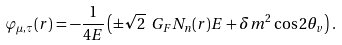<formula> <loc_0><loc_0><loc_500><loc_500>\varphi _ { \mu , \tau } ( r ) = - \frac { 1 } { 4 E } \left ( \pm \sqrt { 2 } \ G _ { F } N _ { n } ( r ) E + \delta m ^ { 2 } \cos { 2 \theta _ { v } } \right ) .</formula> 